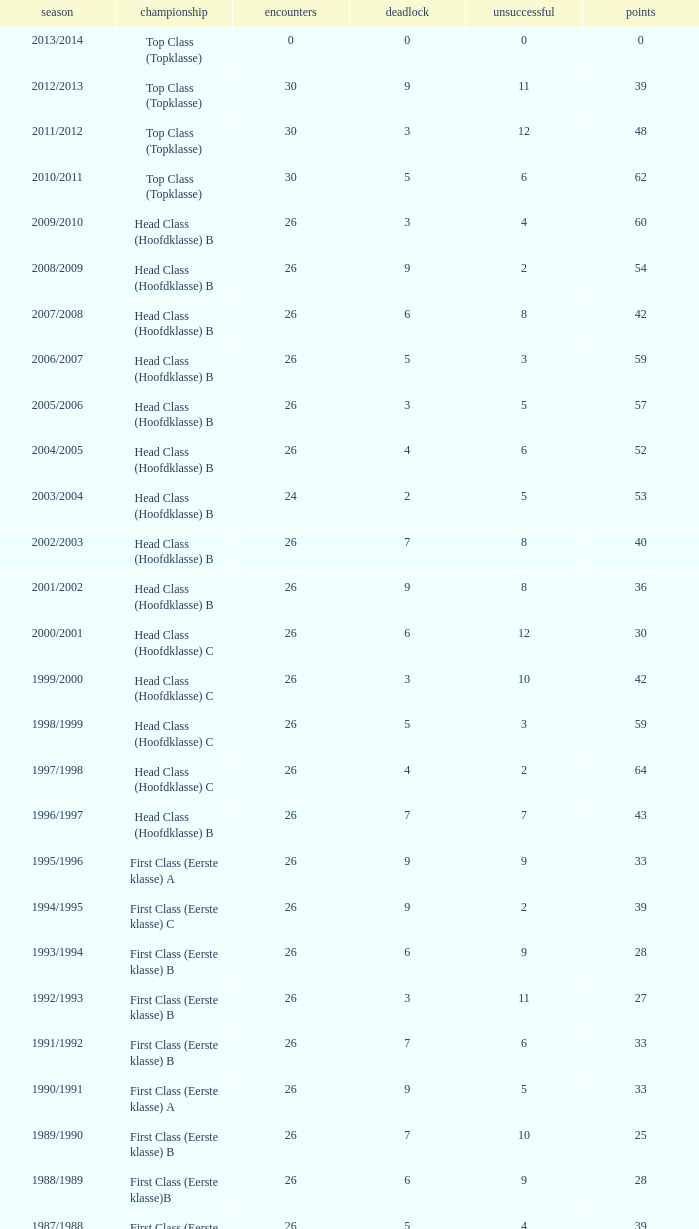What competition has a score greater than 30, a draw less than 5, and a loss larger than 10? Top Class (Topklasse). 